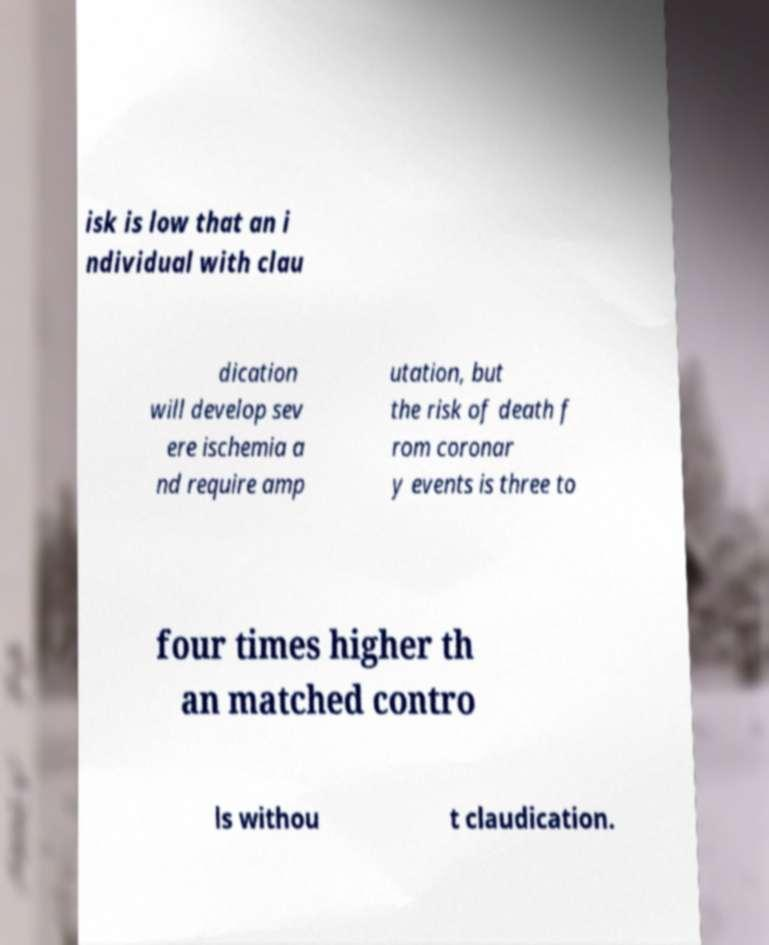Please read and relay the text visible in this image. What does it say? isk is low that an i ndividual with clau dication will develop sev ere ischemia a nd require amp utation, but the risk of death f rom coronar y events is three to four times higher th an matched contro ls withou t claudication. 